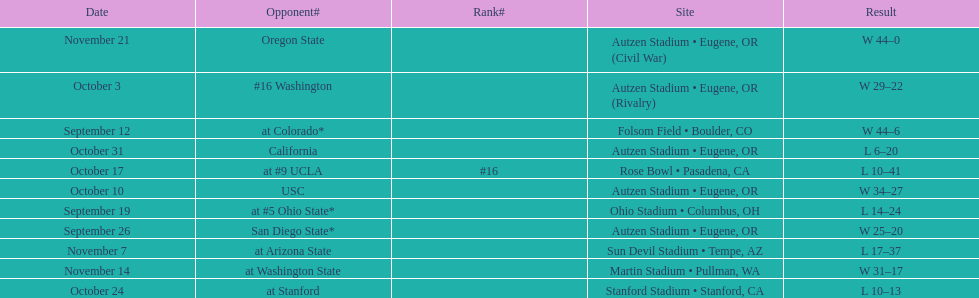Could you parse the entire table as a dict? {'header': ['Date', 'Opponent#', 'Rank#', 'Site', 'Result'], 'rows': [['November 21', 'Oregon State', '', 'Autzen Stadium • Eugene, OR (Civil War)', 'W\xa044–0'], ['October 3', '#16\xa0Washington', '', 'Autzen Stadium • Eugene, OR (Rivalry)', 'W\xa029–22'], ['September 12', 'at\xa0Colorado*', '', 'Folsom Field • Boulder, CO', 'W\xa044–6'], ['October 31', 'California', '', 'Autzen Stadium • Eugene, OR', 'L\xa06–20'], ['October 17', 'at\xa0#9\xa0UCLA', '#16', 'Rose Bowl • Pasadena, CA', 'L\xa010–41'], ['October 10', 'USC', '', 'Autzen Stadium • Eugene, OR', 'W\xa034–27'], ['September 19', 'at\xa0#5\xa0Ohio State*', '', 'Ohio Stadium • Columbus, OH', 'L\xa014–24'], ['September 26', 'San Diego State*', '', 'Autzen Stadium • Eugene, OR', 'W\xa025–20'], ['November 7', 'at\xa0Arizona State', '', 'Sun Devil Stadium • Tempe, AZ', 'L\xa017–37'], ['November 14', 'at\xa0Washington State', '', 'Martin Stadium • Pullman, WA', 'W\xa031–17'], ['October 24', 'at\xa0Stanford', '', 'Stanford Stadium • Stanford, CA', 'L\xa010–13']]} Were the results of the game of november 14 above or below the results of the october 17 game? Above. 